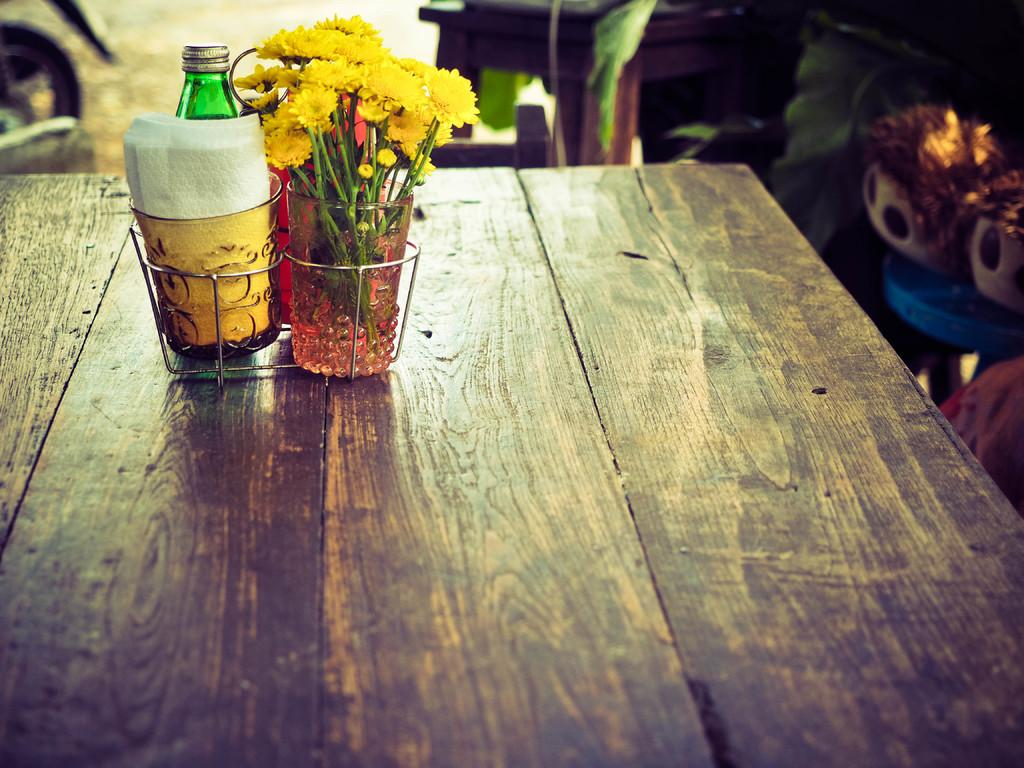What objects are in glasses in the image? There are flowers and tissues in glasses in the image. What is located behind the glasses in the image? There is a bottle behind the glasses in the image. Where are all the items mentioned in the image located? All the items mentioned are on a table. How does the image show respect for nature? The image does not show respect for nature, as it only depicts flowers, tissues, and a bottle on a table. 